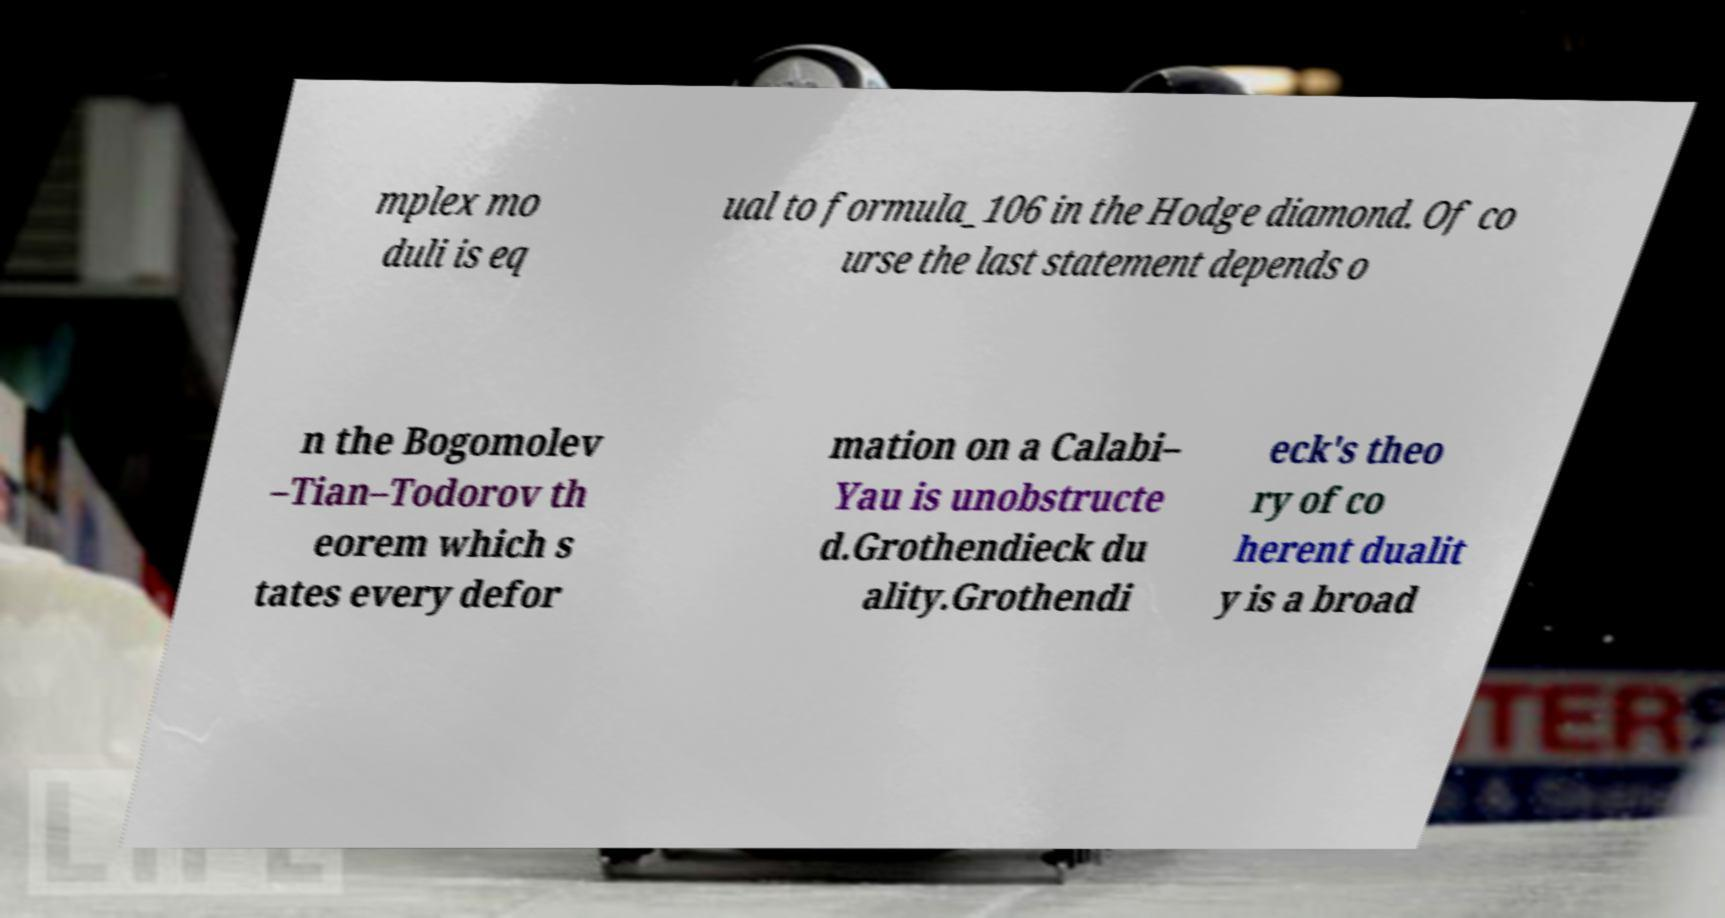There's text embedded in this image that I need extracted. Can you transcribe it verbatim? mplex mo duli is eq ual to formula_106 in the Hodge diamond. Of co urse the last statement depends o n the Bogomolev –Tian–Todorov th eorem which s tates every defor mation on a Calabi– Yau is unobstructe d.Grothendieck du ality.Grothendi eck's theo ry of co herent dualit y is a broad 